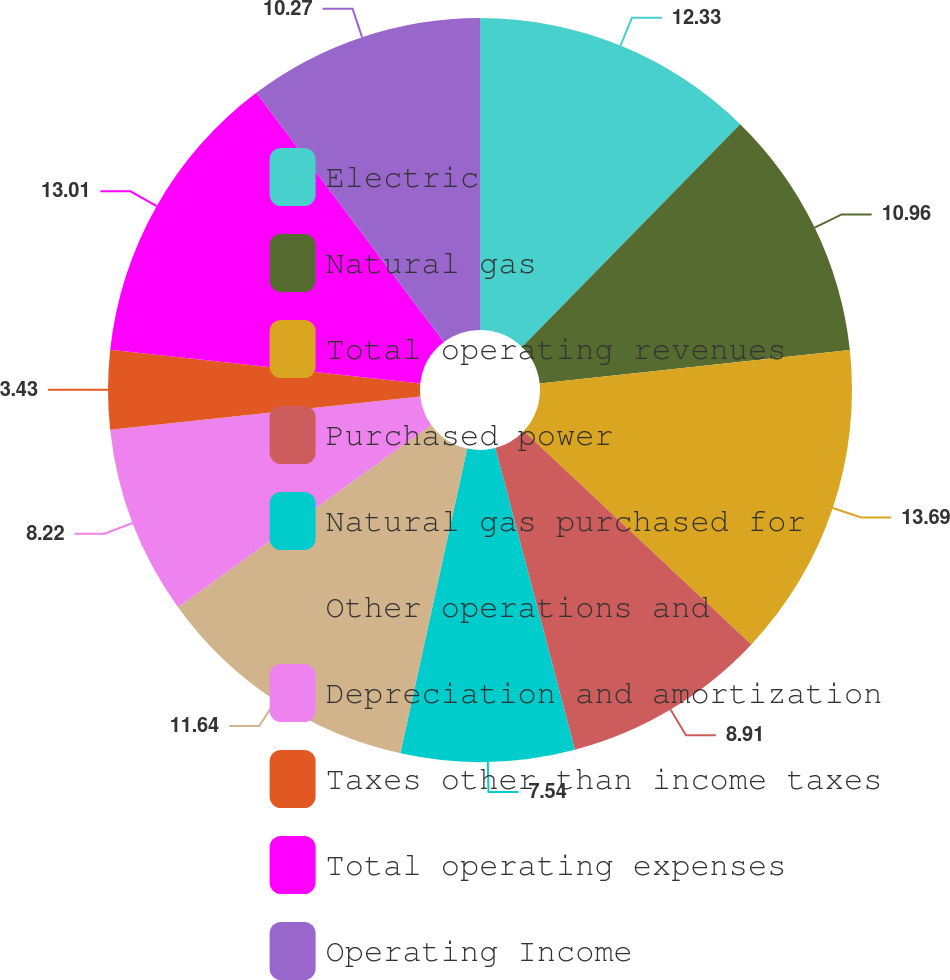<chart> <loc_0><loc_0><loc_500><loc_500><pie_chart><fcel>Electric<fcel>Natural gas<fcel>Total operating revenues<fcel>Purchased power<fcel>Natural gas purchased for<fcel>Other operations and<fcel>Depreciation and amortization<fcel>Taxes other than income taxes<fcel>Total operating expenses<fcel>Operating Income<nl><fcel>12.33%<fcel>10.96%<fcel>13.7%<fcel>8.91%<fcel>7.54%<fcel>11.64%<fcel>8.22%<fcel>3.43%<fcel>13.01%<fcel>10.27%<nl></chart> 